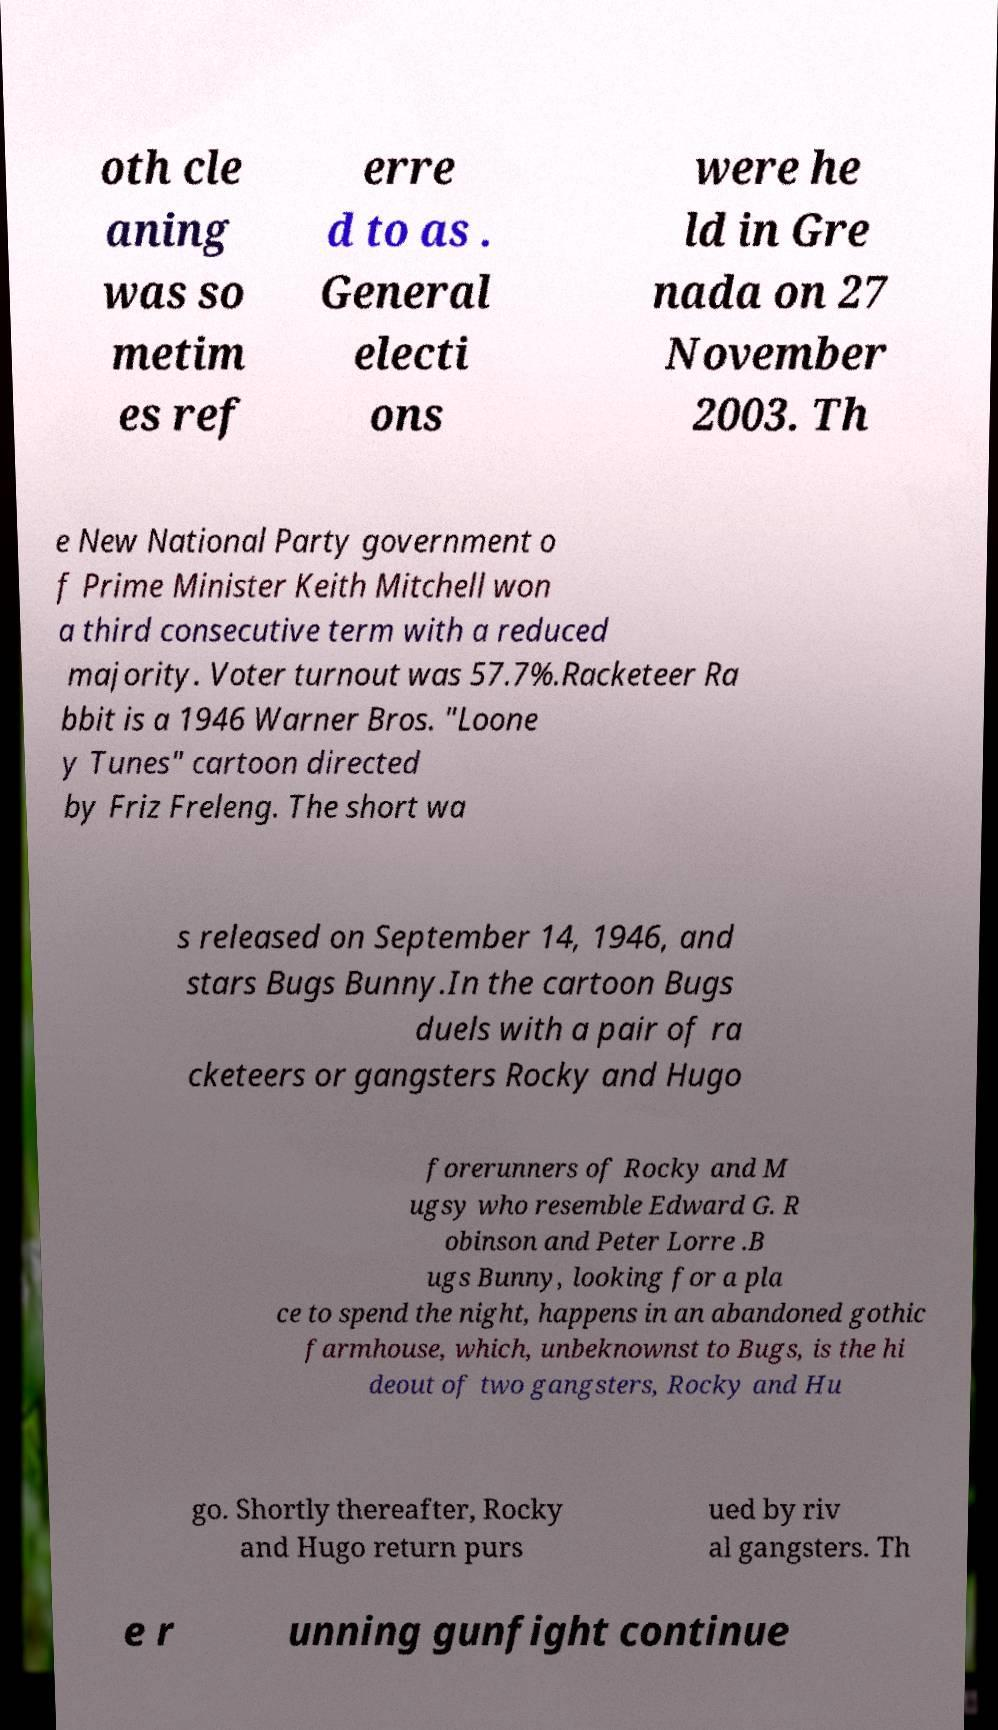I need the written content from this picture converted into text. Can you do that? oth cle aning was so metim es ref erre d to as . General electi ons were he ld in Gre nada on 27 November 2003. Th e New National Party government o f Prime Minister Keith Mitchell won a third consecutive term with a reduced majority. Voter turnout was 57.7%.Racketeer Ra bbit is a 1946 Warner Bros. "Loone y Tunes" cartoon directed by Friz Freleng. The short wa s released on September 14, 1946, and stars Bugs Bunny.In the cartoon Bugs duels with a pair of ra cketeers or gangsters Rocky and Hugo forerunners of Rocky and M ugsy who resemble Edward G. R obinson and Peter Lorre .B ugs Bunny, looking for a pla ce to spend the night, happens in an abandoned gothic farmhouse, which, unbeknownst to Bugs, is the hi deout of two gangsters, Rocky and Hu go. Shortly thereafter, Rocky and Hugo return purs ued by riv al gangsters. Th e r unning gunfight continue 